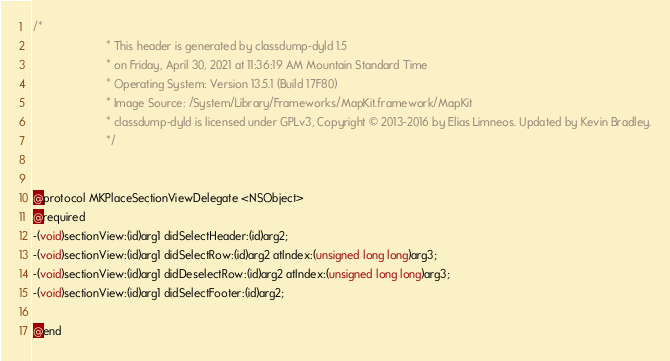Convert code to text. <code><loc_0><loc_0><loc_500><loc_500><_C_>/*
                       * This header is generated by classdump-dyld 1.5
                       * on Friday, April 30, 2021 at 11:36:19 AM Mountain Standard Time
                       * Operating System: Version 13.5.1 (Build 17F80)
                       * Image Source: /System/Library/Frameworks/MapKit.framework/MapKit
                       * classdump-dyld is licensed under GPLv3, Copyright © 2013-2016 by Elias Limneos. Updated by Kevin Bradley.
                       */


@protocol MKPlaceSectionViewDelegate <NSObject>
@required
-(void)sectionView:(id)arg1 didSelectHeader:(id)arg2;
-(void)sectionView:(id)arg1 didSelectRow:(id)arg2 atIndex:(unsigned long long)arg3;
-(void)sectionView:(id)arg1 didDeselectRow:(id)arg2 atIndex:(unsigned long long)arg3;
-(void)sectionView:(id)arg1 didSelectFooter:(id)arg2;

@end

</code> 